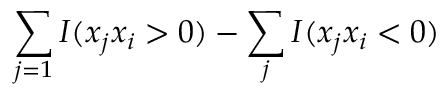Convert formula to latex. <formula><loc_0><loc_0><loc_500><loc_500>\sum _ { j = 1 } I ( x _ { j } x _ { i } > 0 ) - \sum _ { j } I ( x _ { j } x _ { i } < 0 )</formula> 